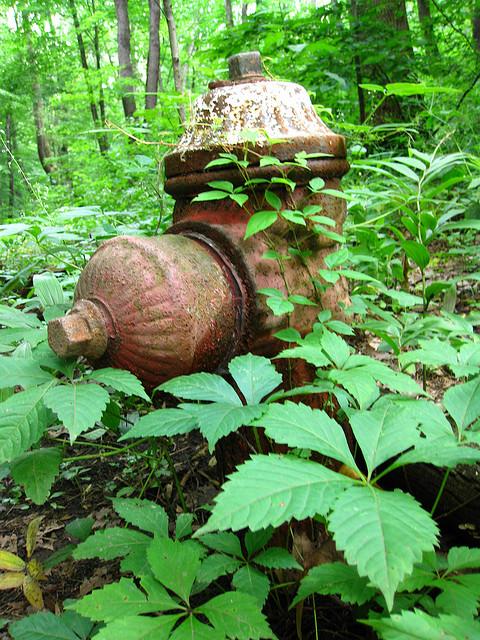What color is the fire hydrant?
Be succinct. Brown. What is the forest?
Be succinct. Fire hydrant. Could that be poison ivy?
Be succinct. Yes. 